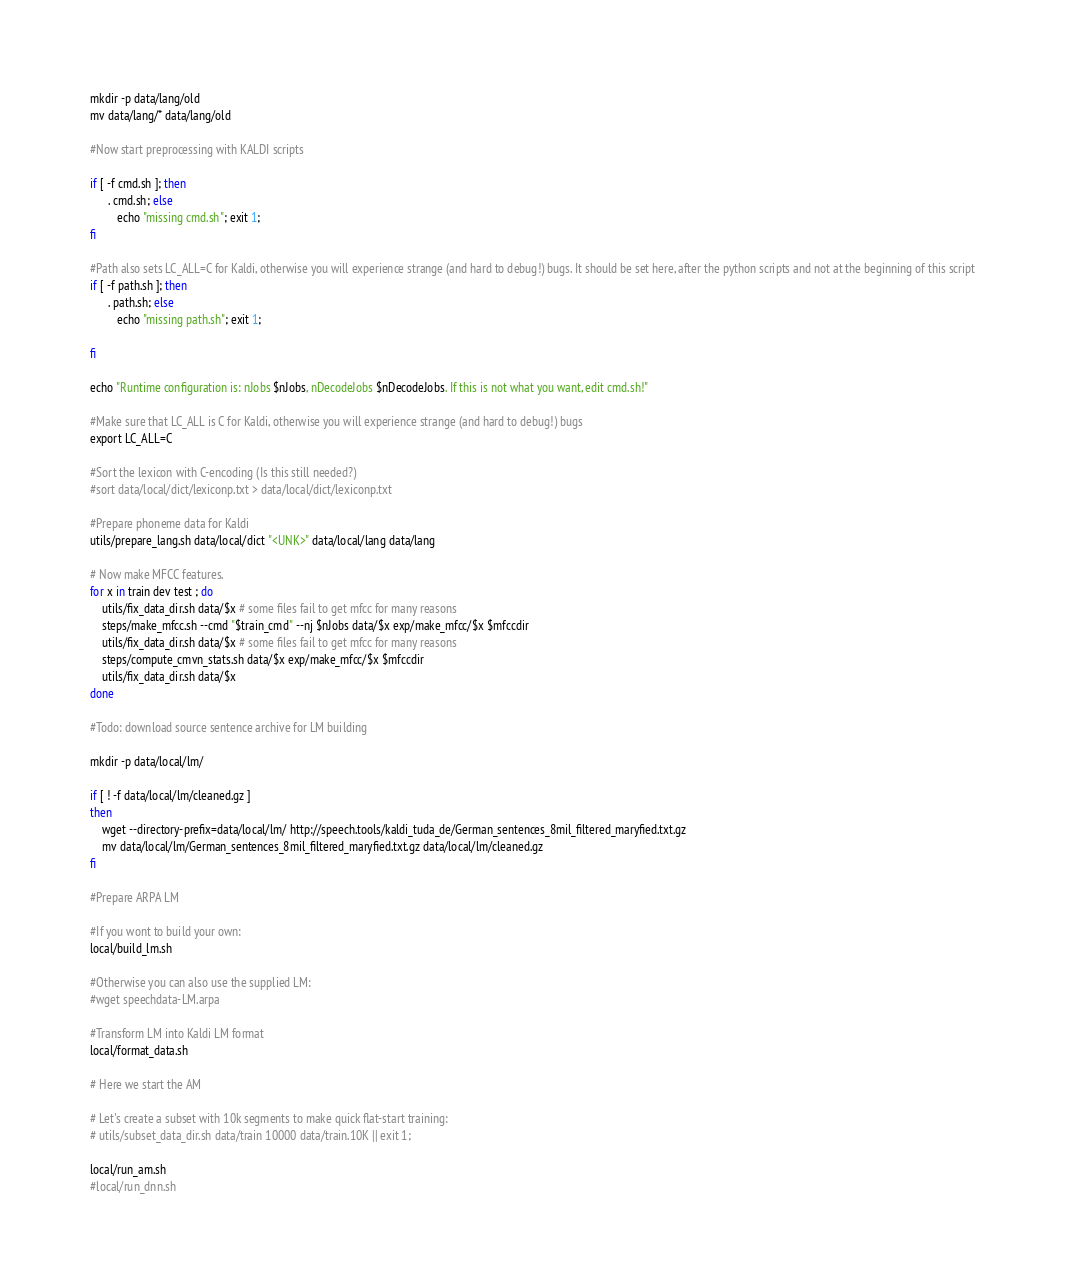Convert code to text. <code><loc_0><loc_0><loc_500><loc_500><_Bash_>mkdir -p data/lang/old
mv data/lang/* data/lang/old

#Now start preprocessing with KALDI scripts

if [ -f cmd.sh ]; then
      . cmd.sh; else
         echo "missing cmd.sh"; exit 1;
fi

#Path also sets LC_ALL=C for Kaldi, otherwise you will experience strange (and hard to debug!) bugs. It should be set here, after the python scripts and not at the beginning of this script
if [ -f path.sh ]; then
      . path.sh; else
         echo "missing path.sh"; exit 1;

fi

echo "Runtime configuration is: nJobs $nJobs, nDecodeJobs $nDecodeJobs. If this is not what you want, edit cmd.sh!"

#Make sure that LC_ALL is C for Kaldi, otherwise you will experience strange (and hard to debug!) bugs
export LC_ALL=C

#Sort the lexicon with C-encoding (Is this still needed?)
#sort data/local/dict/lexiconp.txt > data/local/dict/lexiconp.txt

#Prepare phoneme data for Kaldi
utils/prepare_lang.sh data/local/dict "<UNK>" data/local/lang data/lang

# Now make MFCC features.
for x in train dev test ; do
    utils/fix_data_dir.sh data/$x # some files fail to get mfcc for many reasons
    steps/make_mfcc.sh --cmd "$train_cmd" --nj $nJobs data/$x exp/make_mfcc/$x $mfccdir
    utils/fix_data_dir.sh data/$x # some files fail to get mfcc for many reasons
    steps/compute_cmvn_stats.sh data/$x exp/make_mfcc/$x $mfccdir
    utils/fix_data_dir.sh data/$x
done

#Todo: download source sentence archive for LM building

mkdir -p data/local/lm/

if [ ! -f data/local/lm/cleaned.gz ]
then
    wget --directory-prefix=data/local/lm/ http://speech.tools/kaldi_tuda_de/German_sentences_8mil_filtered_maryfied.txt.gz
    mv data/local/lm/German_sentences_8mil_filtered_maryfied.txt.gz data/local/lm/cleaned.gz
fi

#Prepare ARPA LM

#If you wont to build your own:
local/build_lm.sh

#Otherwise you can also use the supplied LM:
#wget speechdata-LM.arpa

#Transform LM into Kaldi LM format 
local/format_data.sh

# Here we start the AM

# Let's create a subset with 10k segments to make quick flat-start training:
# utils/subset_data_dir.sh data/train 10000 data/train.10K || exit 1;

local/run_am.sh
#local/run_dnn.sh

</code> 